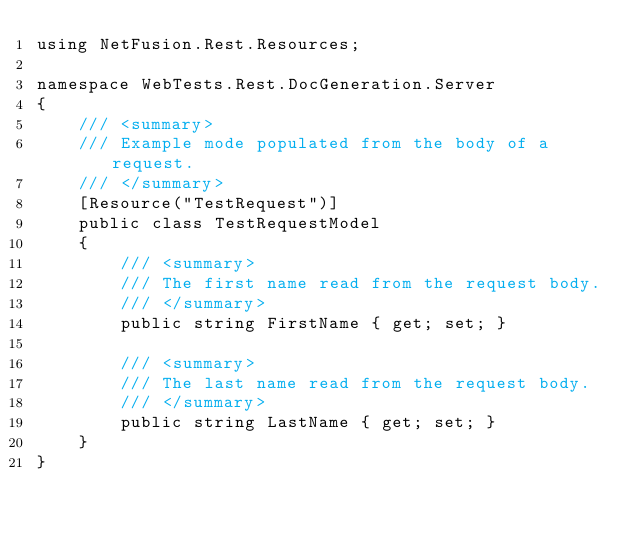<code> <loc_0><loc_0><loc_500><loc_500><_C#_>using NetFusion.Rest.Resources;

namespace WebTests.Rest.DocGeneration.Server
{
    /// <summary>
    /// Example mode populated from the body of a request.
    /// </summary>
    [Resource("TestRequest")]
    public class TestRequestModel
    {
        /// <summary>
        /// The first name read from the request body.
        /// </summary>
        public string FirstName { get; set; }
        
        /// <summary>
        /// The last name read from the request body.
        /// </summary>
        public string LastName { get; set; }
    }
}</code> 